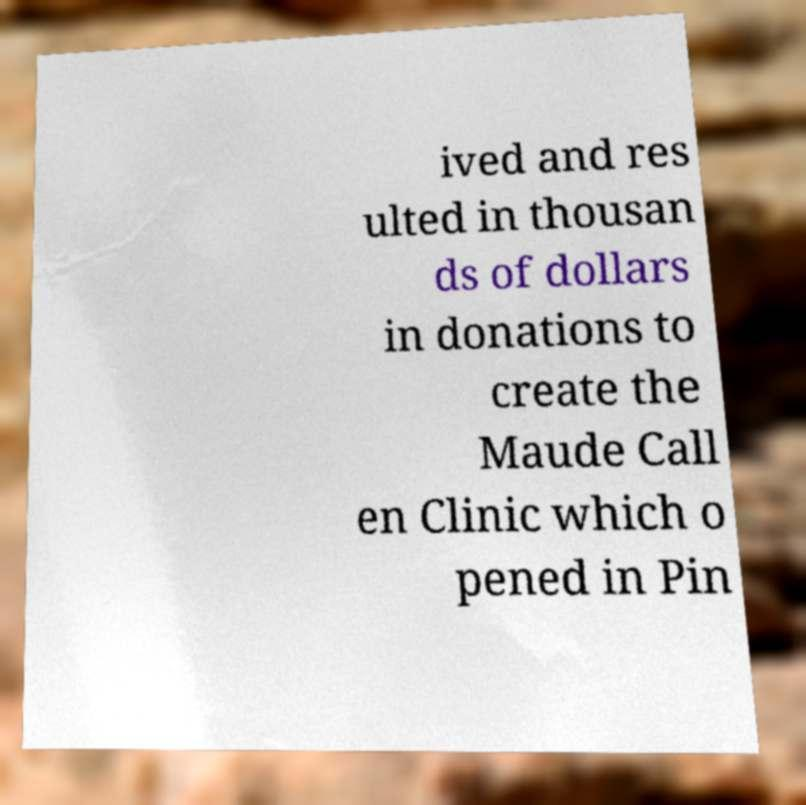I need the written content from this picture converted into text. Can you do that? ived and res ulted in thousan ds of dollars in donations to create the Maude Call en Clinic which o pened in Pin 